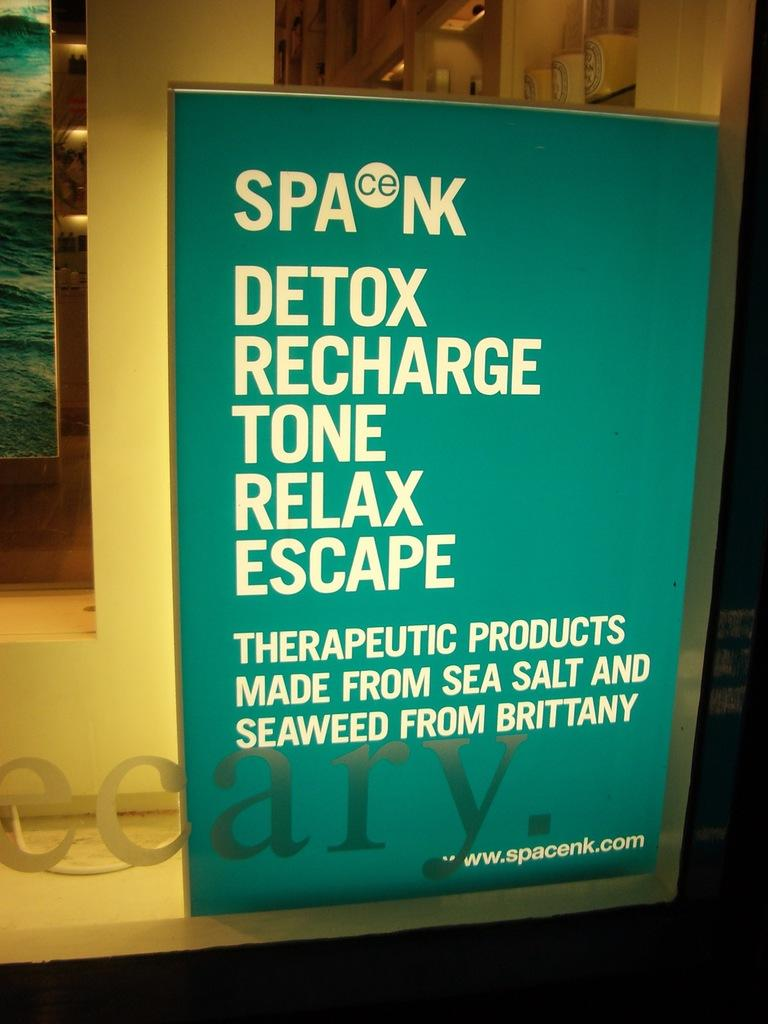<image>
Summarize the visual content of the image. The ad on the window is for a website called www.spacenk.com 